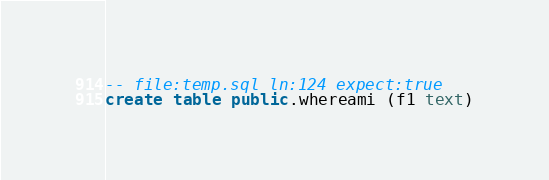<code> <loc_0><loc_0><loc_500><loc_500><_SQL_>-- file:temp.sql ln:124 expect:true
create table public.whereami (f1 text)
</code> 